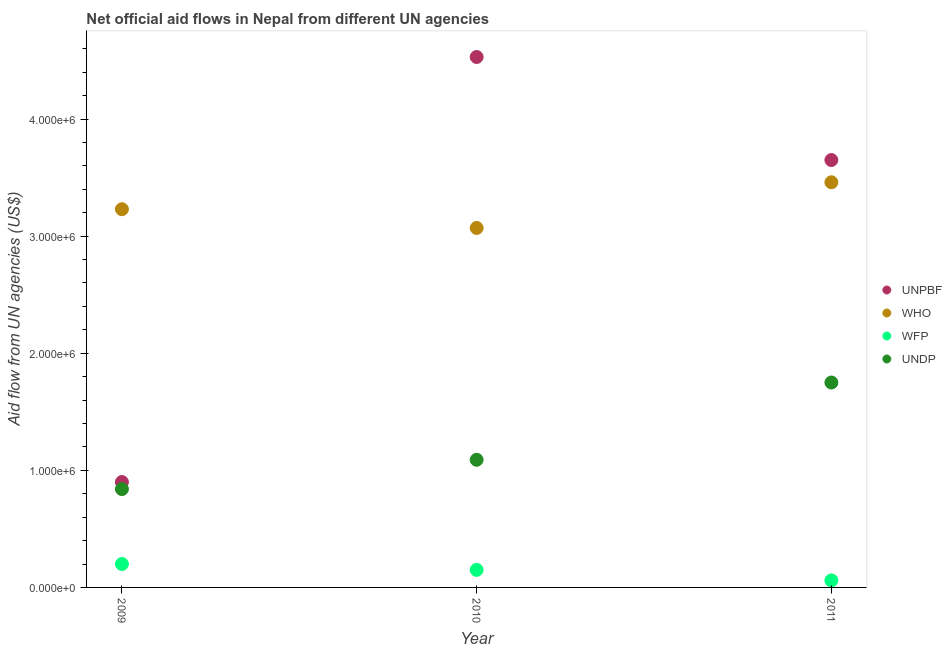What is the amount of aid given by unpbf in 2010?
Offer a terse response. 4.53e+06. Across all years, what is the maximum amount of aid given by undp?
Your answer should be compact. 1.75e+06. Across all years, what is the minimum amount of aid given by undp?
Provide a short and direct response. 8.40e+05. In which year was the amount of aid given by who minimum?
Provide a succinct answer. 2010. What is the total amount of aid given by wfp in the graph?
Keep it short and to the point. 4.10e+05. What is the difference between the amount of aid given by undp in 2010 and that in 2011?
Keep it short and to the point. -6.60e+05. What is the difference between the amount of aid given by unpbf in 2011 and the amount of aid given by who in 2009?
Provide a short and direct response. 4.20e+05. What is the average amount of aid given by wfp per year?
Your answer should be very brief. 1.37e+05. In the year 2009, what is the difference between the amount of aid given by unpbf and amount of aid given by wfp?
Provide a succinct answer. 7.00e+05. In how many years, is the amount of aid given by wfp greater than 1800000 US$?
Ensure brevity in your answer.  0. What is the ratio of the amount of aid given by undp in 2009 to that in 2011?
Your response must be concise. 0.48. Is the difference between the amount of aid given by undp in 2010 and 2011 greater than the difference between the amount of aid given by who in 2010 and 2011?
Make the answer very short. No. What is the difference between the highest and the second highest amount of aid given by undp?
Offer a very short reply. 6.60e+05. What is the difference between the highest and the lowest amount of aid given by who?
Keep it short and to the point. 3.90e+05. Is it the case that in every year, the sum of the amount of aid given by undp and amount of aid given by unpbf is greater than the sum of amount of aid given by wfp and amount of aid given by who?
Your answer should be very brief. No. Is the amount of aid given by who strictly less than the amount of aid given by wfp over the years?
Give a very brief answer. No. How many years are there in the graph?
Your answer should be very brief. 3. What is the difference between two consecutive major ticks on the Y-axis?
Your answer should be very brief. 1.00e+06. Are the values on the major ticks of Y-axis written in scientific E-notation?
Offer a very short reply. Yes. Does the graph contain grids?
Ensure brevity in your answer.  No. How are the legend labels stacked?
Keep it short and to the point. Vertical. What is the title of the graph?
Your answer should be very brief. Net official aid flows in Nepal from different UN agencies. What is the label or title of the Y-axis?
Your answer should be compact. Aid flow from UN agencies (US$). What is the Aid flow from UN agencies (US$) in UNPBF in 2009?
Provide a short and direct response. 9.00e+05. What is the Aid flow from UN agencies (US$) in WHO in 2009?
Provide a short and direct response. 3.23e+06. What is the Aid flow from UN agencies (US$) in WFP in 2009?
Your answer should be compact. 2.00e+05. What is the Aid flow from UN agencies (US$) in UNDP in 2009?
Provide a short and direct response. 8.40e+05. What is the Aid flow from UN agencies (US$) of UNPBF in 2010?
Your answer should be very brief. 4.53e+06. What is the Aid flow from UN agencies (US$) in WHO in 2010?
Make the answer very short. 3.07e+06. What is the Aid flow from UN agencies (US$) of WFP in 2010?
Your answer should be very brief. 1.50e+05. What is the Aid flow from UN agencies (US$) in UNDP in 2010?
Offer a very short reply. 1.09e+06. What is the Aid flow from UN agencies (US$) in UNPBF in 2011?
Your answer should be very brief. 3.65e+06. What is the Aid flow from UN agencies (US$) of WHO in 2011?
Make the answer very short. 3.46e+06. What is the Aid flow from UN agencies (US$) in UNDP in 2011?
Ensure brevity in your answer.  1.75e+06. Across all years, what is the maximum Aid flow from UN agencies (US$) in UNPBF?
Ensure brevity in your answer.  4.53e+06. Across all years, what is the maximum Aid flow from UN agencies (US$) of WHO?
Your answer should be compact. 3.46e+06. Across all years, what is the maximum Aid flow from UN agencies (US$) in WFP?
Ensure brevity in your answer.  2.00e+05. Across all years, what is the maximum Aid flow from UN agencies (US$) in UNDP?
Your answer should be very brief. 1.75e+06. Across all years, what is the minimum Aid flow from UN agencies (US$) of WHO?
Give a very brief answer. 3.07e+06. Across all years, what is the minimum Aid flow from UN agencies (US$) of WFP?
Ensure brevity in your answer.  6.00e+04. Across all years, what is the minimum Aid flow from UN agencies (US$) of UNDP?
Keep it short and to the point. 8.40e+05. What is the total Aid flow from UN agencies (US$) of UNPBF in the graph?
Make the answer very short. 9.08e+06. What is the total Aid flow from UN agencies (US$) of WHO in the graph?
Offer a terse response. 9.76e+06. What is the total Aid flow from UN agencies (US$) of WFP in the graph?
Keep it short and to the point. 4.10e+05. What is the total Aid flow from UN agencies (US$) in UNDP in the graph?
Offer a very short reply. 3.68e+06. What is the difference between the Aid flow from UN agencies (US$) in UNPBF in 2009 and that in 2010?
Offer a terse response. -3.63e+06. What is the difference between the Aid flow from UN agencies (US$) of WHO in 2009 and that in 2010?
Your response must be concise. 1.60e+05. What is the difference between the Aid flow from UN agencies (US$) in UNPBF in 2009 and that in 2011?
Keep it short and to the point. -2.75e+06. What is the difference between the Aid flow from UN agencies (US$) in WFP in 2009 and that in 2011?
Your answer should be very brief. 1.40e+05. What is the difference between the Aid flow from UN agencies (US$) in UNDP in 2009 and that in 2011?
Provide a succinct answer. -9.10e+05. What is the difference between the Aid flow from UN agencies (US$) of UNPBF in 2010 and that in 2011?
Give a very brief answer. 8.80e+05. What is the difference between the Aid flow from UN agencies (US$) in WHO in 2010 and that in 2011?
Offer a terse response. -3.90e+05. What is the difference between the Aid flow from UN agencies (US$) of UNDP in 2010 and that in 2011?
Provide a short and direct response. -6.60e+05. What is the difference between the Aid flow from UN agencies (US$) in UNPBF in 2009 and the Aid flow from UN agencies (US$) in WHO in 2010?
Provide a succinct answer. -2.17e+06. What is the difference between the Aid flow from UN agencies (US$) of UNPBF in 2009 and the Aid flow from UN agencies (US$) of WFP in 2010?
Keep it short and to the point. 7.50e+05. What is the difference between the Aid flow from UN agencies (US$) of WHO in 2009 and the Aid flow from UN agencies (US$) of WFP in 2010?
Offer a very short reply. 3.08e+06. What is the difference between the Aid flow from UN agencies (US$) in WHO in 2009 and the Aid flow from UN agencies (US$) in UNDP in 2010?
Offer a very short reply. 2.14e+06. What is the difference between the Aid flow from UN agencies (US$) of WFP in 2009 and the Aid flow from UN agencies (US$) of UNDP in 2010?
Offer a very short reply. -8.90e+05. What is the difference between the Aid flow from UN agencies (US$) in UNPBF in 2009 and the Aid flow from UN agencies (US$) in WHO in 2011?
Give a very brief answer. -2.56e+06. What is the difference between the Aid flow from UN agencies (US$) in UNPBF in 2009 and the Aid flow from UN agencies (US$) in WFP in 2011?
Provide a short and direct response. 8.40e+05. What is the difference between the Aid flow from UN agencies (US$) of UNPBF in 2009 and the Aid flow from UN agencies (US$) of UNDP in 2011?
Provide a short and direct response. -8.50e+05. What is the difference between the Aid flow from UN agencies (US$) in WHO in 2009 and the Aid flow from UN agencies (US$) in WFP in 2011?
Ensure brevity in your answer.  3.17e+06. What is the difference between the Aid flow from UN agencies (US$) of WHO in 2009 and the Aid flow from UN agencies (US$) of UNDP in 2011?
Your response must be concise. 1.48e+06. What is the difference between the Aid flow from UN agencies (US$) in WFP in 2009 and the Aid flow from UN agencies (US$) in UNDP in 2011?
Provide a short and direct response. -1.55e+06. What is the difference between the Aid flow from UN agencies (US$) of UNPBF in 2010 and the Aid flow from UN agencies (US$) of WHO in 2011?
Your answer should be very brief. 1.07e+06. What is the difference between the Aid flow from UN agencies (US$) of UNPBF in 2010 and the Aid flow from UN agencies (US$) of WFP in 2011?
Make the answer very short. 4.47e+06. What is the difference between the Aid flow from UN agencies (US$) in UNPBF in 2010 and the Aid flow from UN agencies (US$) in UNDP in 2011?
Your answer should be compact. 2.78e+06. What is the difference between the Aid flow from UN agencies (US$) of WHO in 2010 and the Aid flow from UN agencies (US$) of WFP in 2011?
Ensure brevity in your answer.  3.01e+06. What is the difference between the Aid flow from UN agencies (US$) of WHO in 2010 and the Aid flow from UN agencies (US$) of UNDP in 2011?
Offer a terse response. 1.32e+06. What is the difference between the Aid flow from UN agencies (US$) of WFP in 2010 and the Aid flow from UN agencies (US$) of UNDP in 2011?
Give a very brief answer. -1.60e+06. What is the average Aid flow from UN agencies (US$) of UNPBF per year?
Provide a succinct answer. 3.03e+06. What is the average Aid flow from UN agencies (US$) of WHO per year?
Offer a terse response. 3.25e+06. What is the average Aid flow from UN agencies (US$) of WFP per year?
Provide a short and direct response. 1.37e+05. What is the average Aid flow from UN agencies (US$) of UNDP per year?
Give a very brief answer. 1.23e+06. In the year 2009, what is the difference between the Aid flow from UN agencies (US$) in UNPBF and Aid flow from UN agencies (US$) in WHO?
Ensure brevity in your answer.  -2.33e+06. In the year 2009, what is the difference between the Aid flow from UN agencies (US$) of UNPBF and Aid flow from UN agencies (US$) of WFP?
Your answer should be compact. 7.00e+05. In the year 2009, what is the difference between the Aid flow from UN agencies (US$) in WHO and Aid flow from UN agencies (US$) in WFP?
Your answer should be compact. 3.03e+06. In the year 2009, what is the difference between the Aid flow from UN agencies (US$) of WHO and Aid flow from UN agencies (US$) of UNDP?
Ensure brevity in your answer.  2.39e+06. In the year 2009, what is the difference between the Aid flow from UN agencies (US$) in WFP and Aid flow from UN agencies (US$) in UNDP?
Provide a succinct answer. -6.40e+05. In the year 2010, what is the difference between the Aid flow from UN agencies (US$) in UNPBF and Aid flow from UN agencies (US$) in WHO?
Ensure brevity in your answer.  1.46e+06. In the year 2010, what is the difference between the Aid flow from UN agencies (US$) in UNPBF and Aid flow from UN agencies (US$) in WFP?
Provide a short and direct response. 4.38e+06. In the year 2010, what is the difference between the Aid flow from UN agencies (US$) of UNPBF and Aid flow from UN agencies (US$) of UNDP?
Provide a succinct answer. 3.44e+06. In the year 2010, what is the difference between the Aid flow from UN agencies (US$) of WHO and Aid flow from UN agencies (US$) of WFP?
Keep it short and to the point. 2.92e+06. In the year 2010, what is the difference between the Aid flow from UN agencies (US$) in WHO and Aid flow from UN agencies (US$) in UNDP?
Offer a very short reply. 1.98e+06. In the year 2010, what is the difference between the Aid flow from UN agencies (US$) in WFP and Aid flow from UN agencies (US$) in UNDP?
Offer a very short reply. -9.40e+05. In the year 2011, what is the difference between the Aid flow from UN agencies (US$) of UNPBF and Aid flow from UN agencies (US$) of WHO?
Offer a terse response. 1.90e+05. In the year 2011, what is the difference between the Aid flow from UN agencies (US$) in UNPBF and Aid flow from UN agencies (US$) in WFP?
Make the answer very short. 3.59e+06. In the year 2011, what is the difference between the Aid flow from UN agencies (US$) of UNPBF and Aid flow from UN agencies (US$) of UNDP?
Your answer should be compact. 1.90e+06. In the year 2011, what is the difference between the Aid flow from UN agencies (US$) of WHO and Aid flow from UN agencies (US$) of WFP?
Give a very brief answer. 3.40e+06. In the year 2011, what is the difference between the Aid flow from UN agencies (US$) in WHO and Aid flow from UN agencies (US$) in UNDP?
Make the answer very short. 1.71e+06. In the year 2011, what is the difference between the Aid flow from UN agencies (US$) in WFP and Aid flow from UN agencies (US$) in UNDP?
Make the answer very short. -1.69e+06. What is the ratio of the Aid flow from UN agencies (US$) in UNPBF in 2009 to that in 2010?
Your response must be concise. 0.2. What is the ratio of the Aid flow from UN agencies (US$) of WHO in 2009 to that in 2010?
Your response must be concise. 1.05. What is the ratio of the Aid flow from UN agencies (US$) of WFP in 2009 to that in 2010?
Your answer should be compact. 1.33. What is the ratio of the Aid flow from UN agencies (US$) of UNDP in 2009 to that in 2010?
Keep it short and to the point. 0.77. What is the ratio of the Aid flow from UN agencies (US$) of UNPBF in 2009 to that in 2011?
Your answer should be compact. 0.25. What is the ratio of the Aid flow from UN agencies (US$) of WHO in 2009 to that in 2011?
Your response must be concise. 0.93. What is the ratio of the Aid flow from UN agencies (US$) in UNDP in 2009 to that in 2011?
Offer a very short reply. 0.48. What is the ratio of the Aid flow from UN agencies (US$) of UNPBF in 2010 to that in 2011?
Provide a succinct answer. 1.24. What is the ratio of the Aid flow from UN agencies (US$) of WHO in 2010 to that in 2011?
Make the answer very short. 0.89. What is the ratio of the Aid flow from UN agencies (US$) of WFP in 2010 to that in 2011?
Provide a short and direct response. 2.5. What is the ratio of the Aid flow from UN agencies (US$) in UNDP in 2010 to that in 2011?
Your response must be concise. 0.62. What is the difference between the highest and the second highest Aid flow from UN agencies (US$) of UNPBF?
Keep it short and to the point. 8.80e+05. What is the difference between the highest and the second highest Aid flow from UN agencies (US$) of WHO?
Give a very brief answer. 2.30e+05. What is the difference between the highest and the second highest Aid flow from UN agencies (US$) of UNDP?
Provide a succinct answer. 6.60e+05. What is the difference between the highest and the lowest Aid flow from UN agencies (US$) in UNPBF?
Provide a short and direct response. 3.63e+06. What is the difference between the highest and the lowest Aid flow from UN agencies (US$) in WHO?
Provide a succinct answer. 3.90e+05. What is the difference between the highest and the lowest Aid flow from UN agencies (US$) of WFP?
Provide a short and direct response. 1.40e+05. What is the difference between the highest and the lowest Aid flow from UN agencies (US$) of UNDP?
Give a very brief answer. 9.10e+05. 